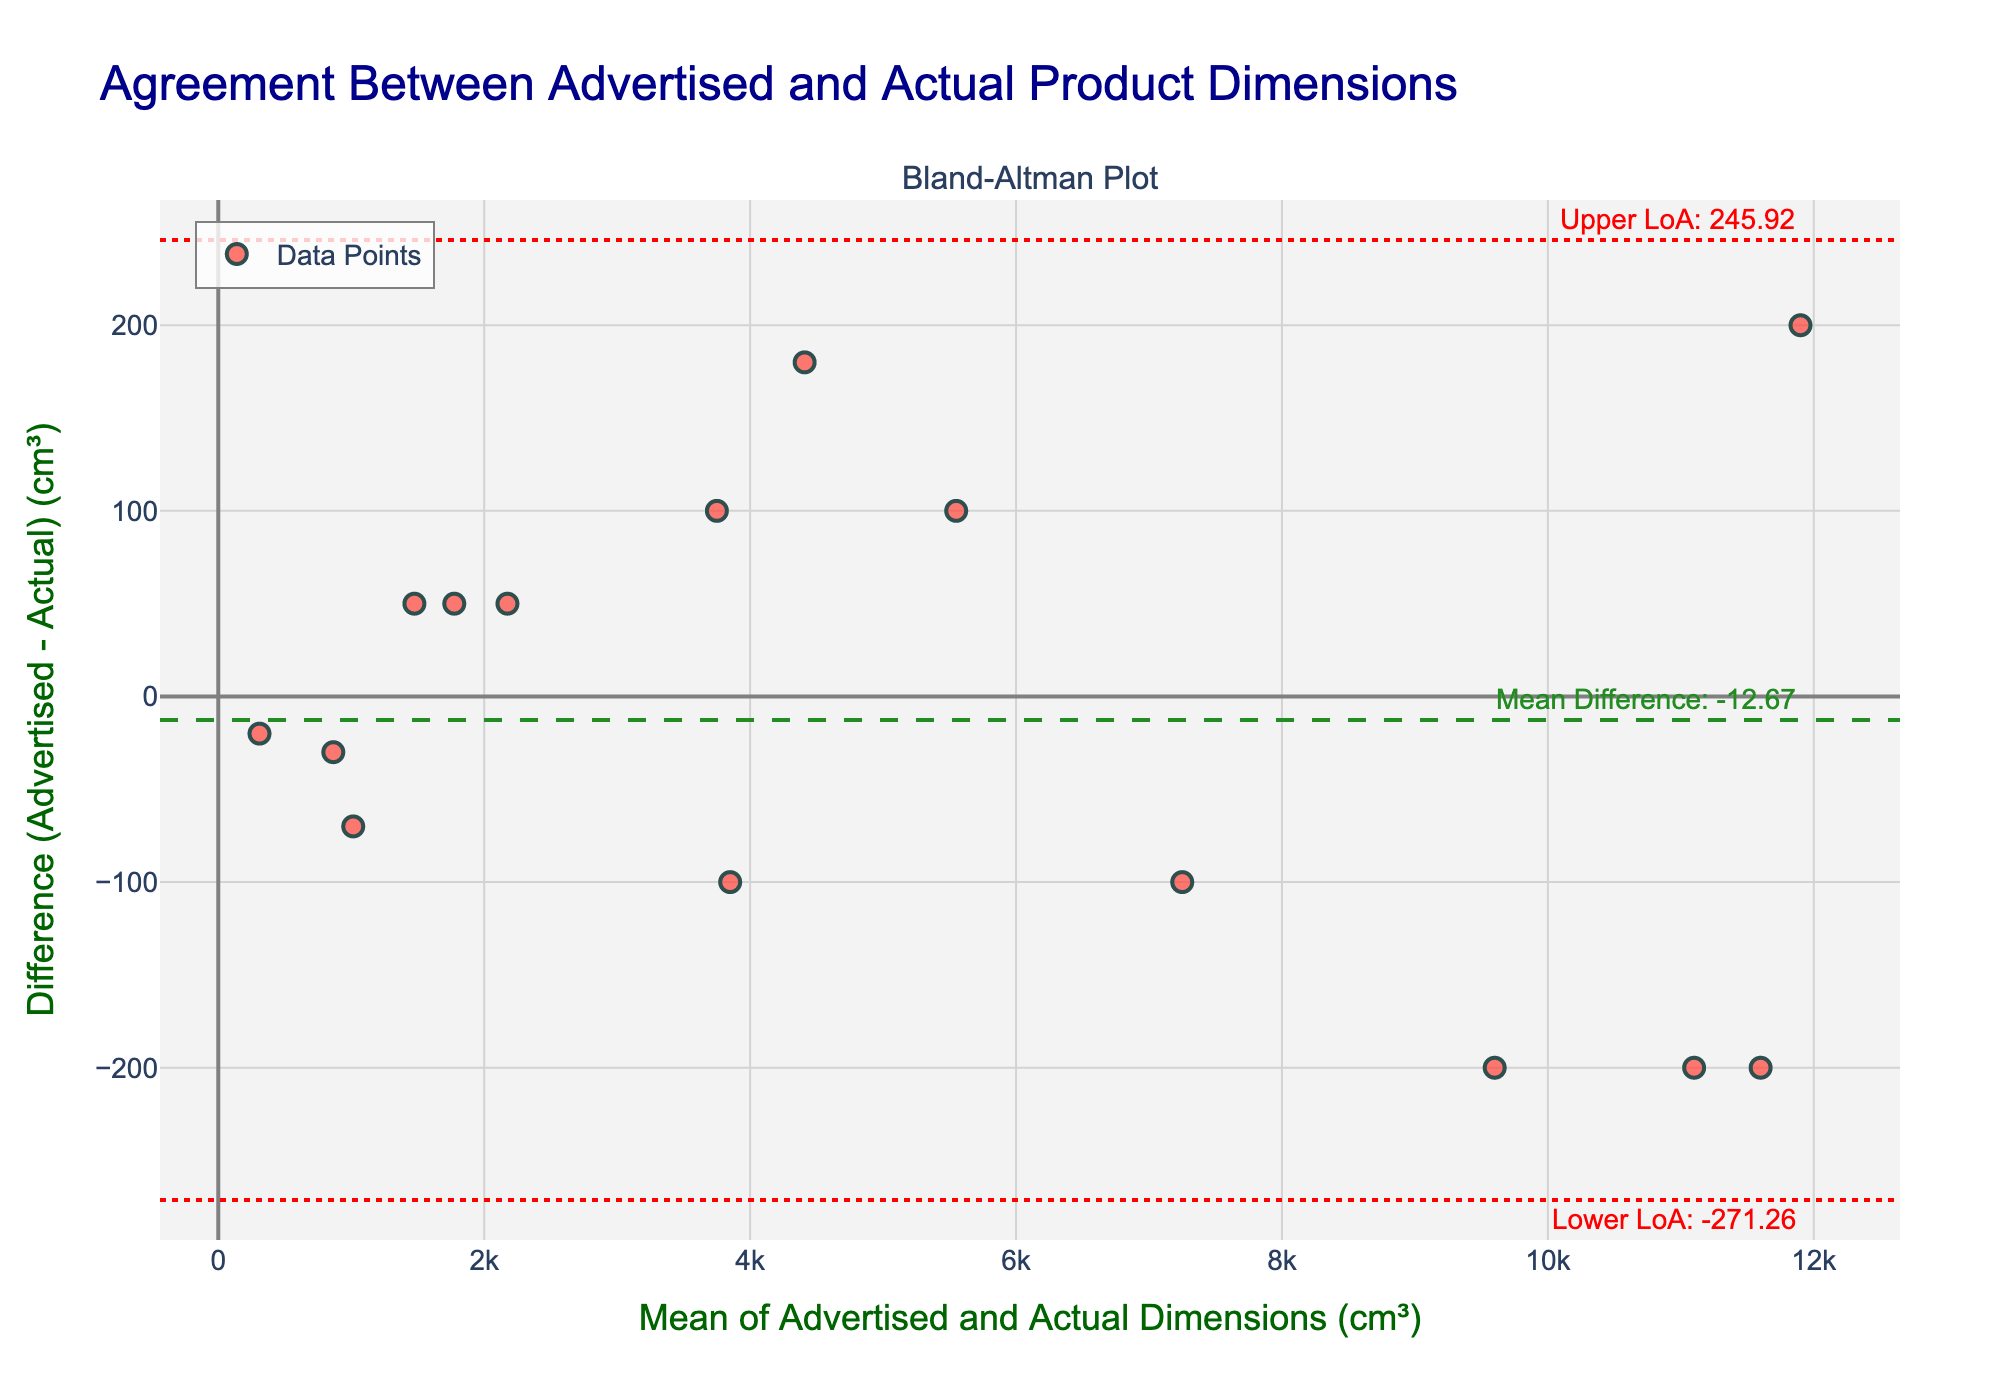What is the title of the plot? The title is typically found at the top of the plot and provides a summary of what the plot is about. In this case, the title is "Agreement Between Advertised and Actual Product Dimensions".
Answer: Agreement Between Advertised and Actual Product Dimensions What does the x-axis represent? The x-axis usually has a label which describes what is being measured. Here, the label for the x-axis is 'Mean of Advertised and Actual Dimensions (cm³)', indicating it represents the average value of the advertised and actual dimensions of the products.
Answer: Mean of Advertised and Actual Dimensions (cm³) How many data points are there in the plot? Each data point on the plot represents a product and is depicted as a marker. By counting the number of markers, one can determine the number of data points.
Answer: 15 What is the mean difference in the plot? The mean difference is represented by a horizontal line, often accompanied by a label. In this plot, you can find the 'Mean Difference' line and its corresponding value in the annotation.
Answer: 14.67 What are the values of the upper and lower limits of agreement? The limits of agreement are shown as two dotted lines, one above and one below the mean difference line. The upper and lower limits of agreement are annotated on the plot.
Answer: Upper LoA: 334.90, Lower LoA: -305.57 Which product has the largest positive difference between advertised and actual dimensions? To find this, look for the data point which is the highest above the mean difference line. By referring to the original data, you can match this point based on its location.
Answer: Samsung Galaxy S21 Phone Box Which product has the smallest mean of advertised and actual dimensions? This would be the data point farthest to the left on the plot. To identify the corresponding product, compare with the original data provided.
Answer: Fitbit Charge 5 Fitness Tracker Are there more points above or below the mean difference line? To answer this, count the number of points above and below the mean difference line (horizontal dashed line). Compare the two counts.
Answer: Below Is there a visible trend in the differences as the mean dimensions increase? To determine this, observe whether the differences (y-axis values) are generally increasing or decreasing as you move from left to right along the x-axis.
Answer: No visible trend How does the plot help in understanding the discrepancy between advertised and actual dimensions? The plot shows the differences (advertised minus actual) against the mean dimensions, with a mean difference line and limits of agreement. It visually indicates how much deviation exists and whether the deviations are consistent across the range.
Answer: Indicates consistency and magnitude of discrepancies 